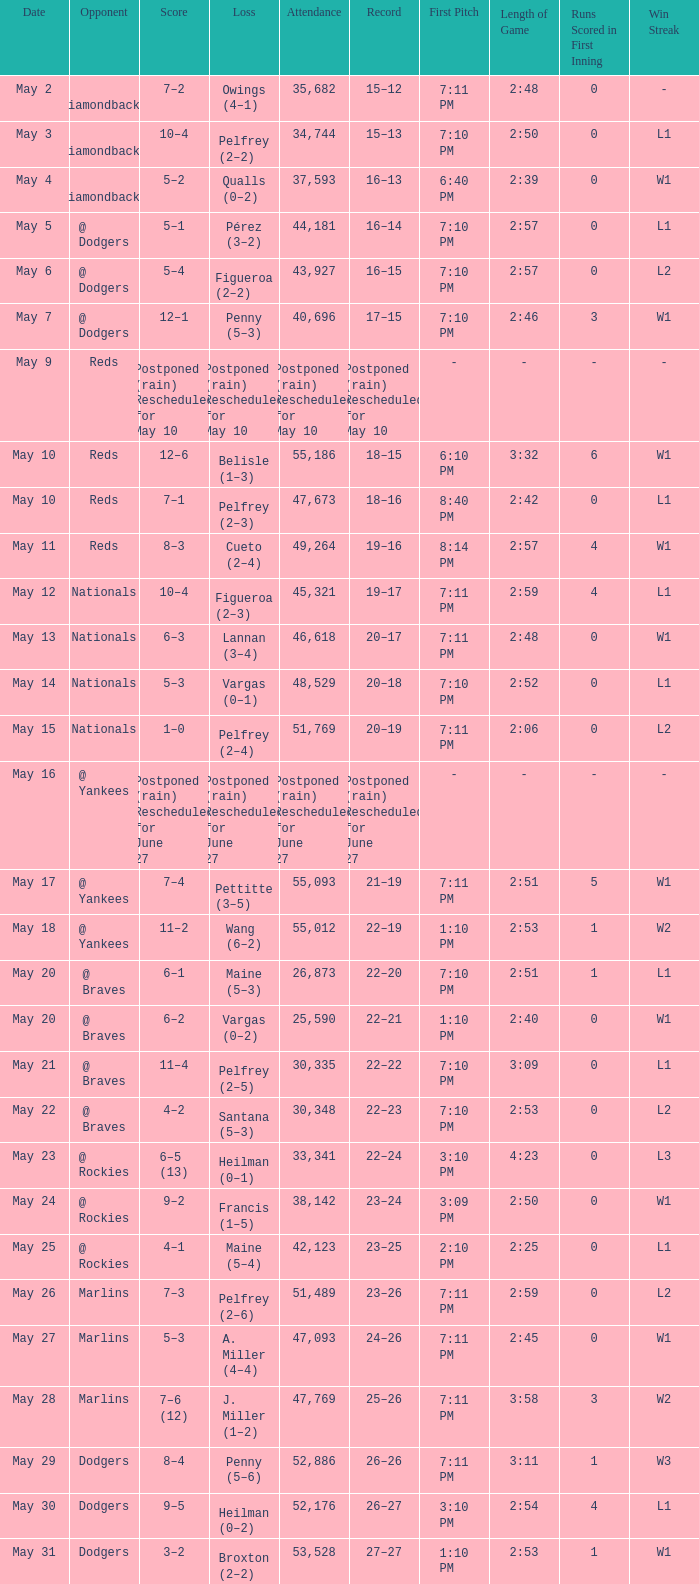Record of 19–16 occurred on what date? May 11. 